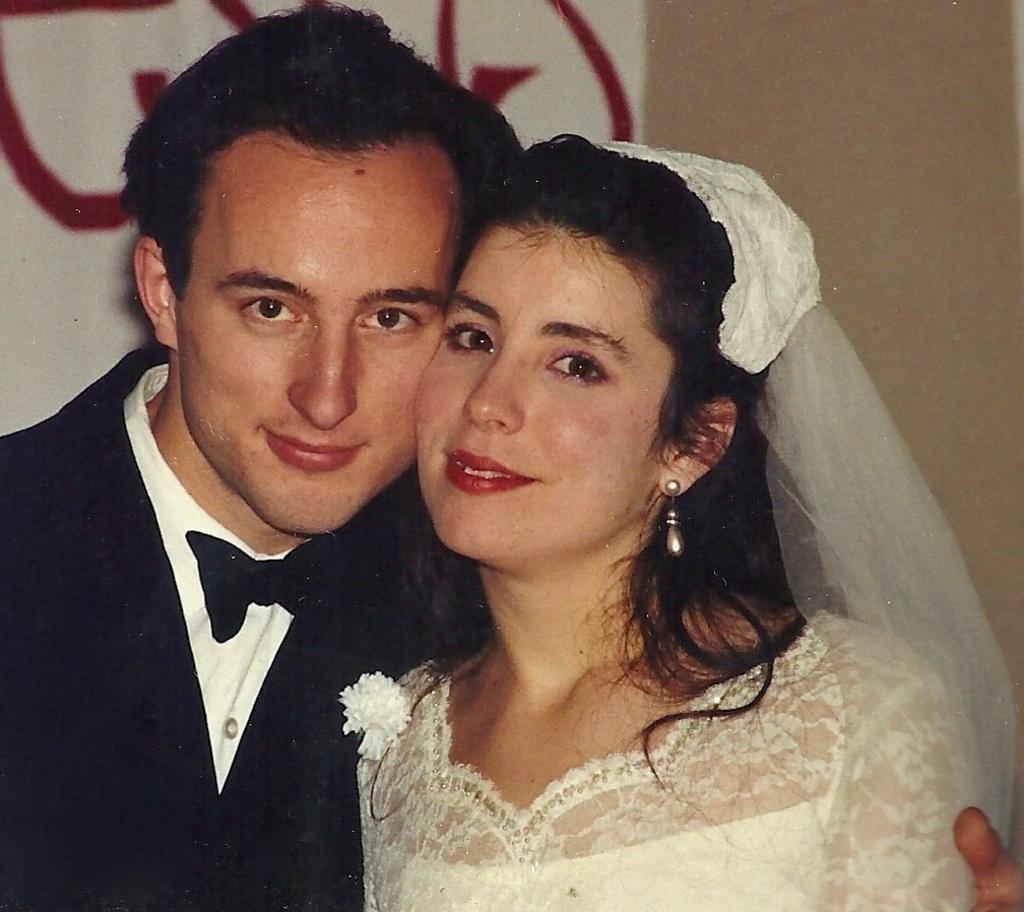Please provide a concise description of this image. In the image we can see a man and a woman wearing clothes and they are smiling, and the woman is wearing earrings, and the background is blurred. 